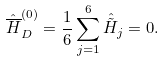Convert formula to latex. <formula><loc_0><loc_0><loc_500><loc_500>\hat { \overline { H } } _ { D } ^ { ( 0 ) } = \frac { 1 } { 6 } \sum _ { j = 1 } ^ { 6 } \hat { \tilde { H } } _ { j } = 0 .</formula> 